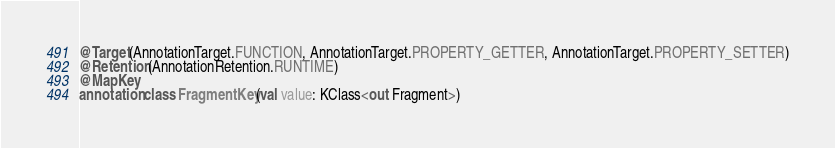Convert code to text. <code><loc_0><loc_0><loc_500><loc_500><_Kotlin_>@Target(AnnotationTarget.FUNCTION, AnnotationTarget.PROPERTY_GETTER, AnnotationTarget.PROPERTY_SETTER)
@Retention(AnnotationRetention.RUNTIME)
@MapKey
annotation class FragmentKey(val value: KClass<out Fragment>)</code> 